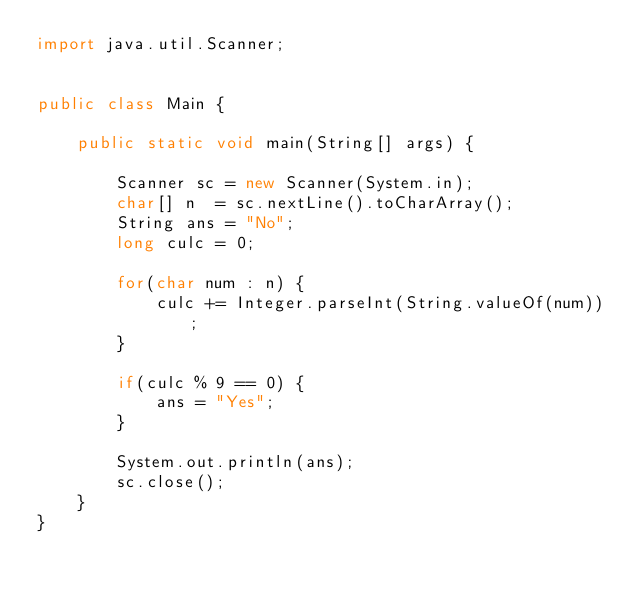<code> <loc_0><loc_0><loc_500><loc_500><_Java_>import java.util.Scanner;

 
public class Main {
 
	public static void main(String[] args) {
		
		Scanner sc = new Scanner(System.in);
		char[] n  = sc.nextLine().toCharArray();
		String ans = "No";
		long culc = 0;

		for(char num : n) {
			culc += Integer.parseInt(String.valueOf(num));
		}
		
		if(culc % 9 == 0) {
			ans = "Yes";
		}
		
		System.out.println(ans);
		sc.close();
	}
}


</code> 